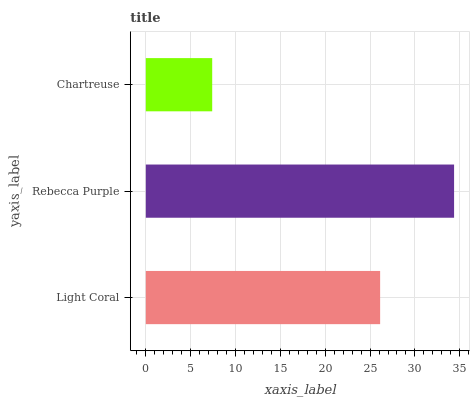Is Chartreuse the minimum?
Answer yes or no. Yes. Is Rebecca Purple the maximum?
Answer yes or no. Yes. Is Rebecca Purple the minimum?
Answer yes or no. No. Is Chartreuse the maximum?
Answer yes or no. No. Is Rebecca Purple greater than Chartreuse?
Answer yes or no. Yes. Is Chartreuse less than Rebecca Purple?
Answer yes or no. Yes. Is Chartreuse greater than Rebecca Purple?
Answer yes or no. No. Is Rebecca Purple less than Chartreuse?
Answer yes or no. No. Is Light Coral the high median?
Answer yes or no. Yes. Is Light Coral the low median?
Answer yes or no. Yes. Is Chartreuse the high median?
Answer yes or no. No. Is Rebecca Purple the low median?
Answer yes or no. No. 